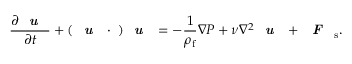<formula> <loc_0><loc_0><loc_500><loc_500>\frac { \partial { u } } { \partial t } + ( u \cdot \nabla ) u = - \frac { 1 } { \rho _ { f } } { \nabla } P + \nu \nabla ^ { 2 } { u } + F _ { s } .</formula> 